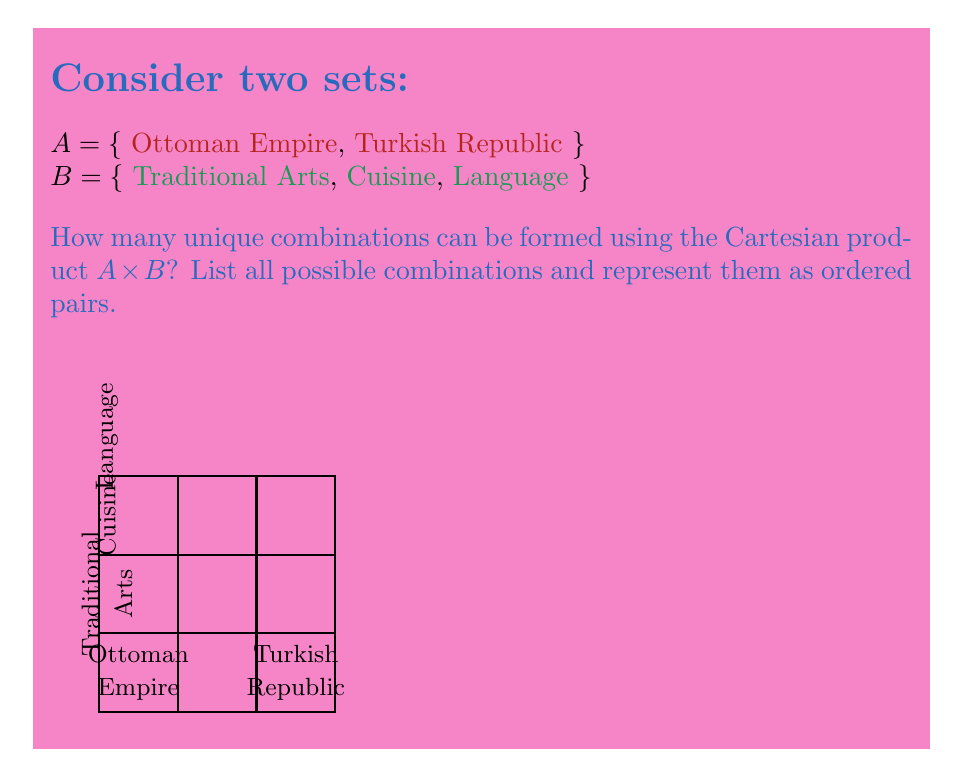What is the answer to this math problem? To solve this problem, we need to understand the Cartesian product and how it applies to sets representing Turkish cultural elements and historical periods.

1) The Cartesian product of two sets $A$ and $B$, denoted as $A \times B$, is the set of all ordered pairs $(a,b)$ where $a \in A$ and $b \in B$.

2) In this case:
   $A = \{$ Ottoman Empire, Turkish Republic $\}$
   $B = \{$ Traditional Arts, Cuisine, Language $\}$

3) The number of elements in the Cartesian product is given by:
   $|A \times B| = |A| \cdot |B|$

4) Here, $|A| = 2$ and $|B| = 3$

5) Therefore, $|A \times B| = 2 \cdot 3 = 6$

6) The actual Cartesian product $A \times B$ is:
   $\{$ (Ottoman Empire, Traditional Arts), 
       (Ottoman Empire, Cuisine), 
       (Ottoman Empire, Language), 
       (Turkish Republic, Traditional Arts), 
       (Turkish Republic, Cuisine), 
       (Turkish Republic, Language) $\}$

Each of these pairs represents a unique combination of a historical period and a cultural element, allowing for a comprehensive exploration of Turkish culture across different eras.
Answer: 6 combinations: $\{$(Ottoman Empire, Traditional Arts), (Ottoman Empire, Cuisine), (Ottoman Empire, Language), (Turkish Republic, Traditional Arts), (Turkish Republic, Cuisine), (Turkish Republic, Language)$\}$ 